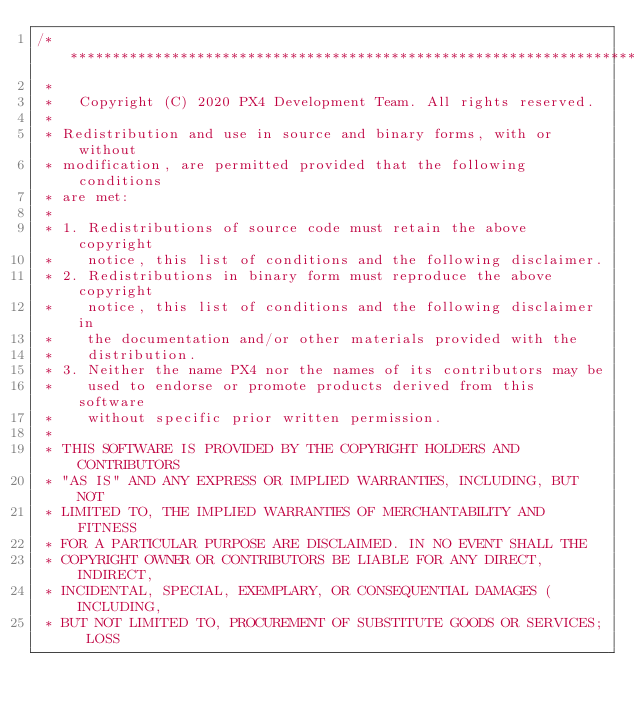Convert code to text. <code><loc_0><loc_0><loc_500><loc_500><_C++_>/****************************************************************************
 *
 *   Copyright (C) 2020 PX4 Development Team. All rights reserved.
 *
 * Redistribution and use in source and binary forms, with or without
 * modification, are permitted provided that the following conditions
 * are met:
 *
 * 1. Redistributions of source code must retain the above copyright
 *    notice, this list of conditions and the following disclaimer.
 * 2. Redistributions in binary form must reproduce the above copyright
 *    notice, this list of conditions and the following disclaimer in
 *    the documentation and/or other materials provided with the
 *    distribution.
 * 3. Neither the name PX4 nor the names of its contributors may be
 *    used to endorse or promote products derived from this software
 *    without specific prior written permission.
 *
 * THIS SOFTWARE IS PROVIDED BY THE COPYRIGHT HOLDERS AND CONTRIBUTORS
 * "AS IS" AND ANY EXPRESS OR IMPLIED WARRANTIES, INCLUDING, BUT NOT
 * LIMITED TO, THE IMPLIED WARRANTIES OF MERCHANTABILITY AND FITNESS
 * FOR A PARTICULAR PURPOSE ARE DISCLAIMED. IN NO EVENT SHALL THE
 * COPYRIGHT OWNER OR CONTRIBUTORS BE LIABLE FOR ANY DIRECT, INDIRECT,
 * INCIDENTAL, SPECIAL, EXEMPLARY, OR CONSEQUENTIAL DAMAGES (INCLUDING,
 * BUT NOT LIMITED TO, PROCUREMENT OF SUBSTITUTE GOODS OR SERVICES; LOSS</code> 